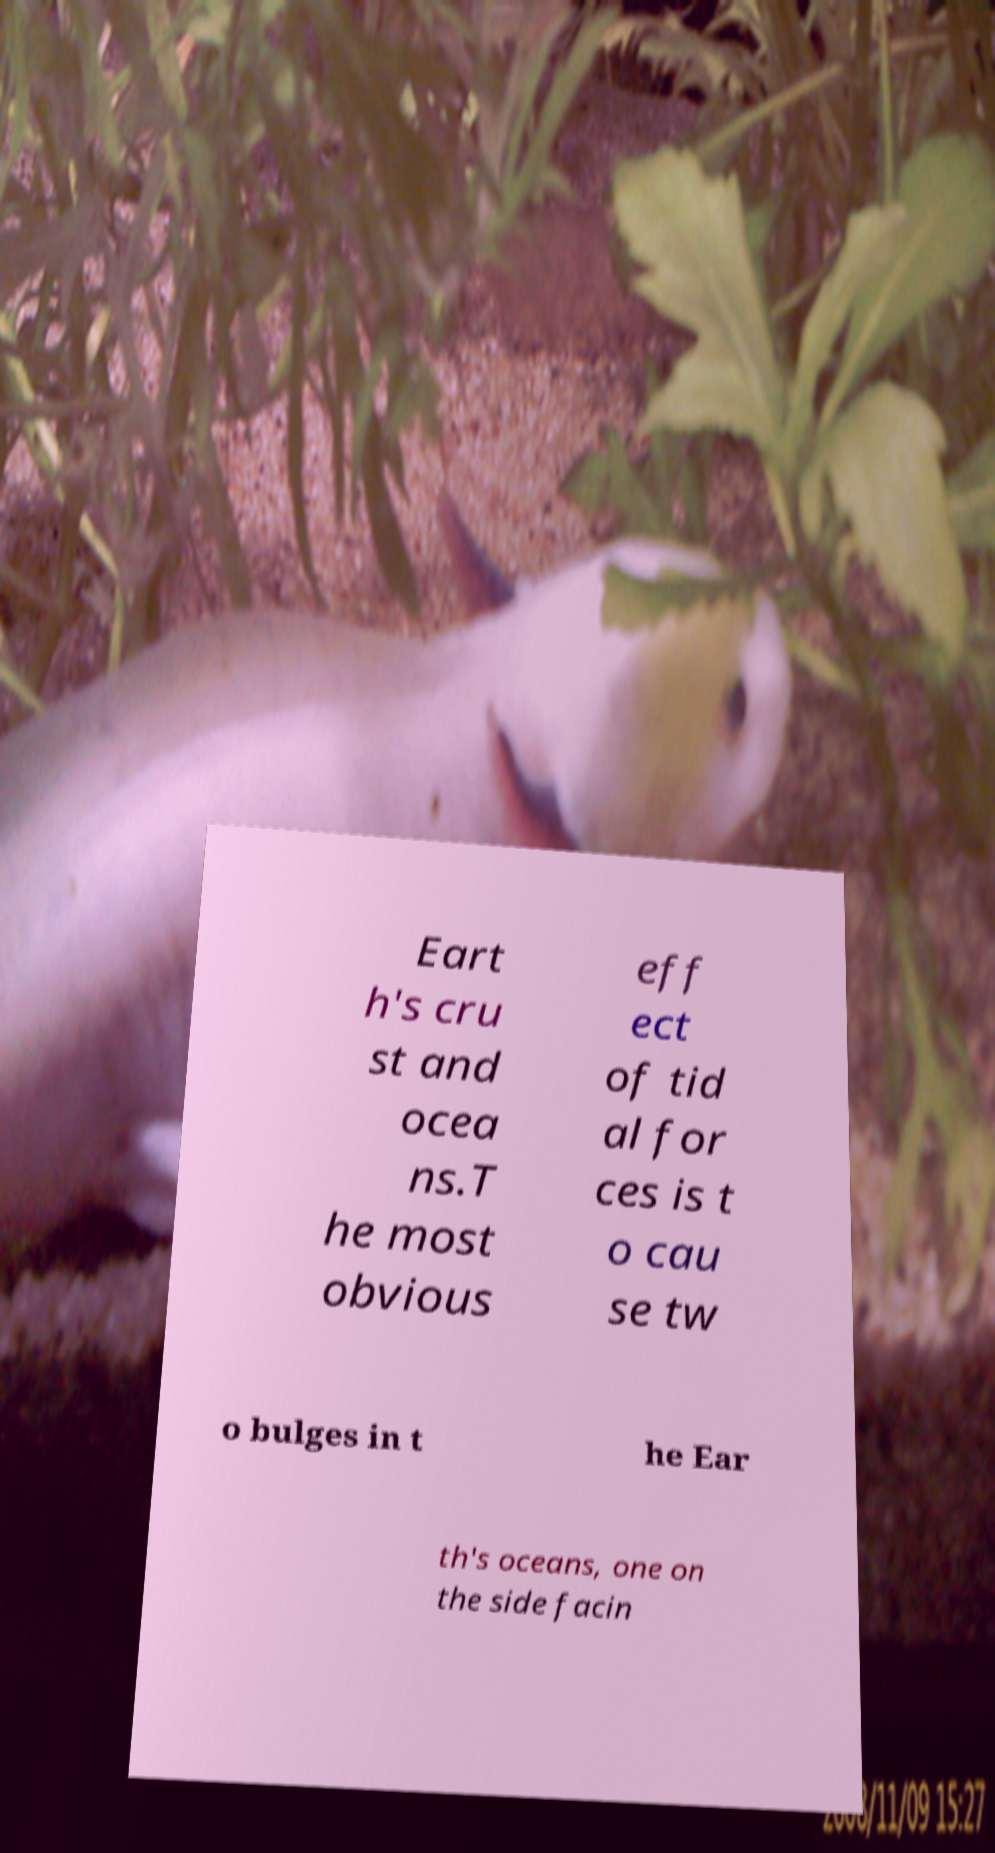For documentation purposes, I need the text within this image transcribed. Could you provide that? Eart h's cru st and ocea ns.T he most obvious eff ect of tid al for ces is t o cau se tw o bulges in t he Ear th's oceans, one on the side facin 